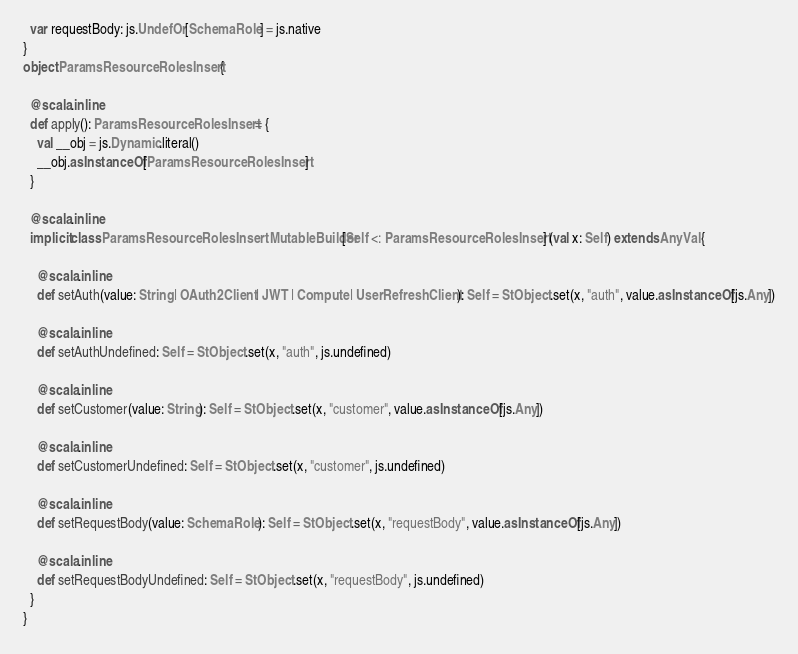<code> <loc_0><loc_0><loc_500><loc_500><_Scala_>  var requestBody: js.UndefOr[SchemaRole] = js.native
}
object ParamsResourceRolesInsert {
  
  @scala.inline
  def apply(): ParamsResourceRolesInsert = {
    val __obj = js.Dynamic.literal()
    __obj.asInstanceOf[ParamsResourceRolesInsert]
  }
  
  @scala.inline
  implicit class ParamsResourceRolesInsertMutableBuilder[Self <: ParamsResourceRolesInsert] (val x: Self) extends AnyVal {
    
    @scala.inline
    def setAuth(value: String | OAuth2Client | JWT | Compute | UserRefreshClient): Self = StObject.set(x, "auth", value.asInstanceOf[js.Any])
    
    @scala.inline
    def setAuthUndefined: Self = StObject.set(x, "auth", js.undefined)
    
    @scala.inline
    def setCustomer(value: String): Self = StObject.set(x, "customer", value.asInstanceOf[js.Any])
    
    @scala.inline
    def setCustomerUndefined: Self = StObject.set(x, "customer", js.undefined)
    
    @scala.inline
    def setRequestBody(value: SchemaRole): Self = StObject.set(x, "requestBody", value.asInstanceOf[js.Any])
    
    @scala.inline
    def setRequestBodyUndefined: Self = StObject.set(x, "requestBody", js.undefined)
  }
}
</code> 